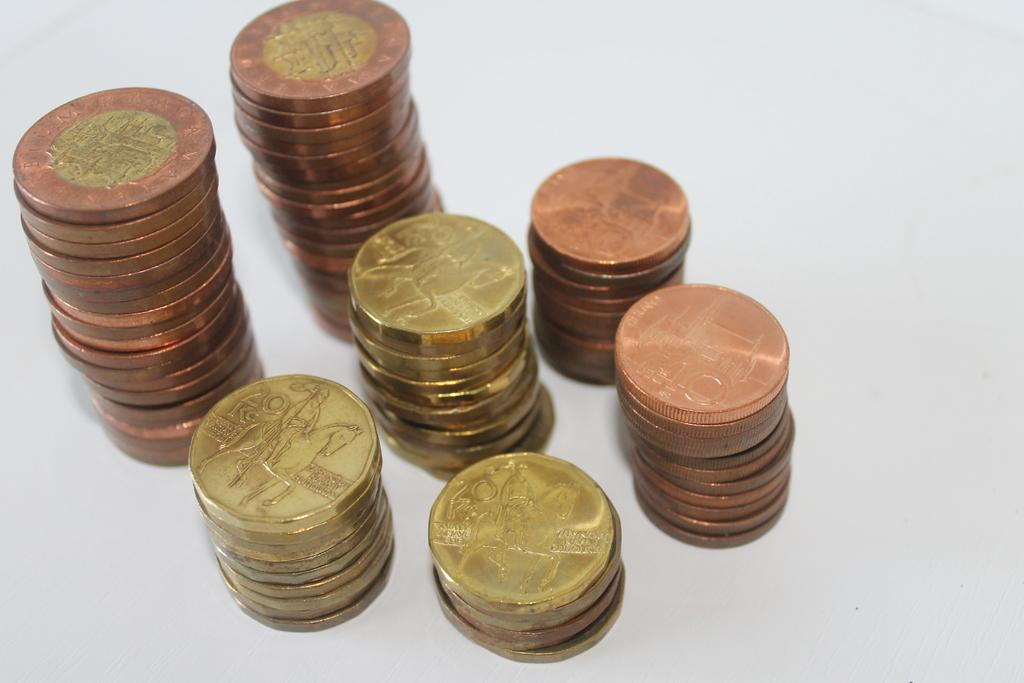<image>
Present a compact description of the photo's key features. Stacks of gold and bronze colored coins in 20, 10 and other denominations of Kc currency. 